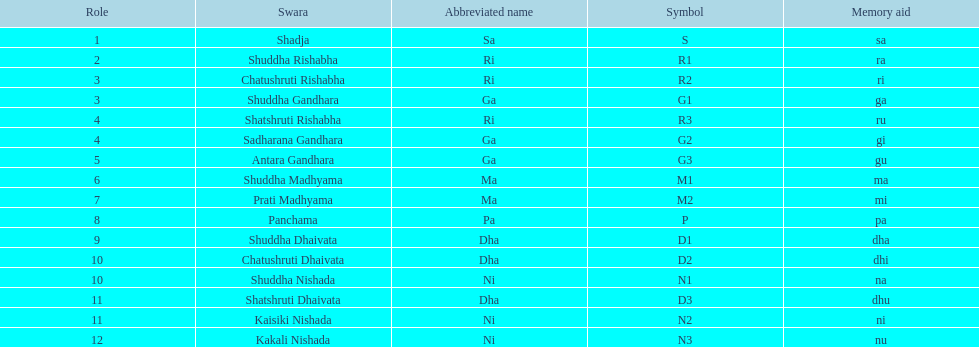On average how many of the swara have a short name that begin with d or g? 6. Can you parse all the data within this table? {'header': ['Role', 'Swara', 'Abbreviated name', 'Symbol', 'Memory aid'], 'rows': [['1', 'Shadja', 'Sa', 'S', 'sa'], ['2', 'Shuddha Rishabha', 'Ri', 'R1', 'ra'], ['3', 'Chatushruti Rishabha', 'Ri', 'R2', 'ri'], ['3', 'Shuddha Gandhara', 'Ga', 'G1', 'ga'], ['4', 'Shatshruti Rishabha', 'Ri', 'R3', 'ru'], ['4', 'Sadharana Gandhara', 'Ga', 'G2', 'gi'], ['5', 'Antara Gandhara', 'Ga', 'G3', 'gu'], ['6', 'Shuddha Madhyama', 'Ma', 'M1', 'ma'], ['7', 'Prati Madhyama', 'Ma', 'M2', 'mi'], ['8', 'Panchama', 'Pa', 'P', 'pa'], ['9', 'Shuddha Dhaivata', 'Dha', 'D1', 'dha'], ['10', 'Chatushruti Dhaivata', 'Dha', 'D2', 'dhi'], ['10', 'Shuddha Nishada', 'Ni', 'N1', 'na'], ['11', 'Shatshruti Dhaivata', 'Dha', 'D3', 'dhu'], ['11', 'Kaisiki Nishada', 'Ni', 'N2', 'ni'], ['12', 'Kakali Nishada', 'Ni', 'N3', 'nu']]} 